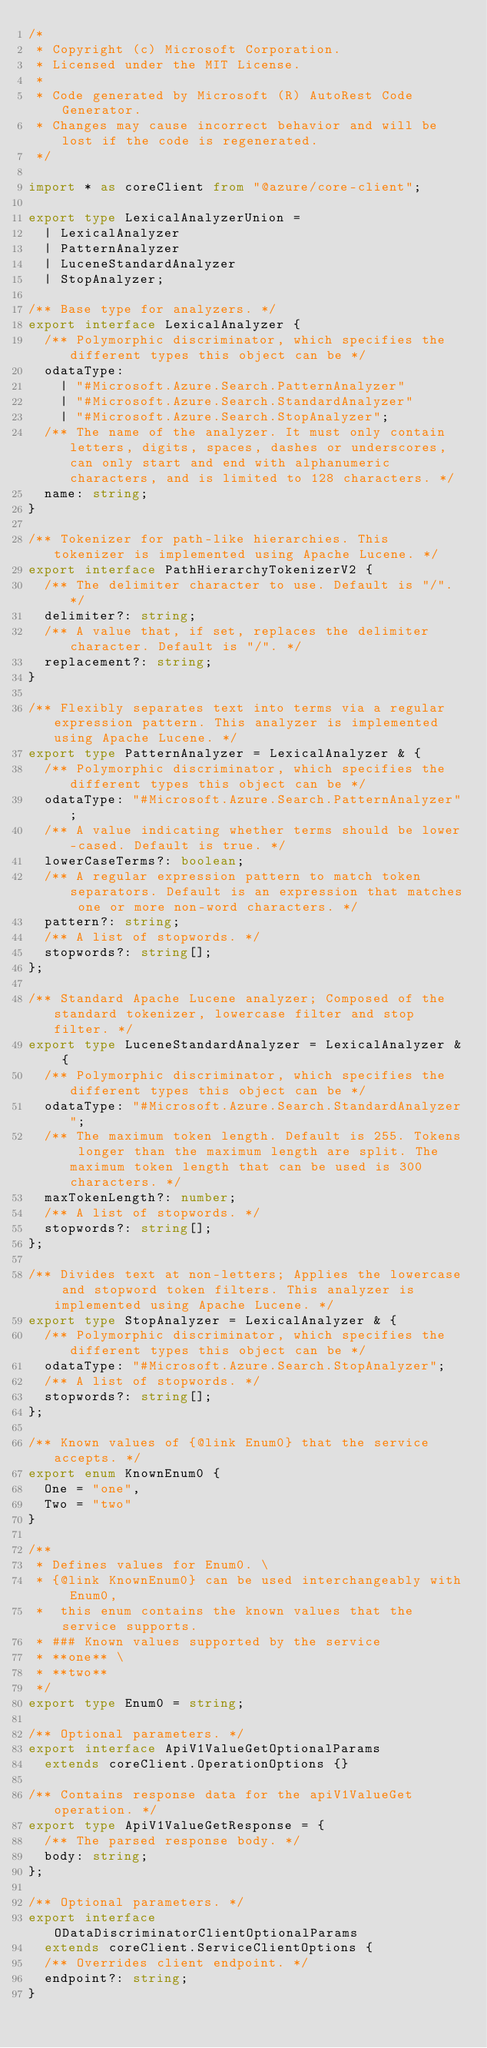<code> <loc_0><loc_0><loc_500><loc_500><_TypeScript_>/*
 * Copyright (c) Microsoft Corporation.
 * Licensed under the MIT License.
 *
 * Code generated by Microsoft (R) AutoRest Code Generator.
 * Changes may cause incorrect behavior and will be lost if the code is regenerated.
 */

import * as coreClient from "@azure/core-client";

export type LexicalAnalyzerUnion =
  | LexicalAnalyzer
  | PatternAnalyzer
  | LuceneStandardAnalyzer
  | StopAnalyzer;

/** Base type for analyzers. */
export interface LexicalAnalyzer {
  /** Polymorphic discriminator, which specifies the different types this object can be */
  odataType:
    | "#Microsoft.Azure.Search.PatternAnalyzer"
    | "#Microsoft.Azure.Search.StandardAnalyzer"
    | "#Microsoft.Azure.Search.StopAnalyzer";
  /** The name of the analyzer. It must only contain letters, digits, spaces, dashes or underscores, can only start and end with alphanumeric characters, and is limited to 128 characters. */
  name: string;
}

/** Tokenizer for path-like hierarchies. This tokenizer is implemented using Apache Lucene. */
export interface PathHierarchyTokenizerV2 {
  /** The delimiter character to use. Default is "/". */
  delimiter?: string;
  /** A value that, if set, replaces the delimiter character. Default is "/". */
  replacement?: string;
}

/** Flexibly separates text into terms via a regular expression pattern. This analyzer is implemented using Apache Lucene. */
export type PatternAnalyzer = LexicalAnalyzer & {
  /** Polymorphic discriminator, which specifies the different types this object can be */
  odataType: "#Microsoft.Azure.Search.PatternAnalyzer";
  /** A value indicating whether terms should be lower-cased. Default is true. */
  lowerCaseTerms?: boolean;
  /** A regular expression pattern to match token separators. Default is an expression that matches one or more non-word characters. */
  pattern?: string;
  /** A list of stopwords. */
  stopwords?: string[];
};

/** Standard Apache Lucene analyzer; Composed of the standard tokenizer, lowercase filter and stop filter. */
export type LuceneStandardAnalyzer = LexicalAnalyzer & {
  /** Polymorphic discriminator, which specifies the different types this object can be */
  odataType: "#Microsoft.Azure.Search.StandardAnalyzer";
  /** The maximum token length. Default is 255. Tokens longer than the maximum length are split. The maximum token length that can be used is 300 characters. */
  maxTokenLength?: number;
  /** A list of stopwords. */
  stopwords?: string[];
};

/** Divides text at non-letters; Applies the lowercase and stopword token filters. This analyzer is implemented using Apache Lucene. */
export type StopAnalyzer = LexicalAnalyzer & {
  /** Polymorphic discriminator, which specifies the different types this object can be */
  odataType: "#Microsoft.Azure.Search.StopAnalyzer";
  /** A list of stopwords. */
  stopwords?: string[];
};

/** Known values of {@link Enum0} that the service accepts. */
export enum KnownEnum0 {
  One = "one",
  Two = "two"
}

/**
 * Defines values for Enum0. \
 * {@link KnownEnum0} can be used interchangeably with Enum0,
 *  this enum contains the known values that the service supports.
 * ### Known values supported by the service
 * **one** \
 * **two**
 */
export type Enum0 = string;

/** Optional parameters. */
export interface ApiV1ValueGetOptionalParams
  extends coreClient.OperationOptions {}

/** Contains response data for the apiV1ValueGet operation. */
export type ApiV1ValueGetResponse = {
  /** The parsed response body. */
  body: string;
};

/** Optional parameters. */
export interface ODataDiscriminatorClientOptionalParams
  extends coreClient.ServiceClientOptions {
  /** Overrides client endpoint. */
  endpoint?: string;
}
</code> 